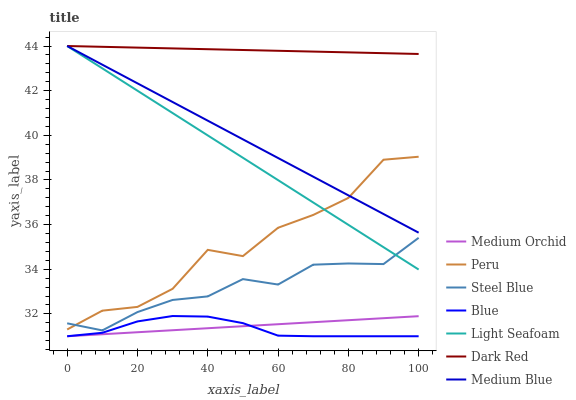Does Blue have the minimum area under the curve?
Answer yes or no. Yes. Does Dark Red have the maximum area under the curve?
Answer yes or no. Yes. Does Medium Orchid have the minimum area under the curve?
Answer yes or no. No. Does Medium Orchid have the maximum area under the curve?
Answer yes or no. No. Is Medium Orchid the smoothest?
Answer yes or no. Yes. Is Peru the roughest?
Answer yes or no. Yes. Is Dark Red the smoothest?
Answer yes or no. No. Is Dark Red the roughest?
Answer yes or no. No. Does Blue have the lowest value?
Answer yes or no. Yes. Does Dark Red have the lowest value?
Answer yes or no. No. Does Light Seafoam have the highest value?
Answer yes or no. Yes. Does Medium Orchid have the highest value?
Answer yes or no. No. Is Medium Orchid less than Peru?
Answer yes or no. Yes. Is Dark Red greater than Medium Orchid?
Answer yes or no. Yes. Does Light Seafoam intersect Dark Red?
Answer yes or no. Yes. Is Light Seafoam less than Dark Red?
Answer yes or no. No. Is Light Seafoam greater than Dark Red?
Answer yes or no. No. Does Medium Orchid intersect Peru?
Answer yes or no. No. 